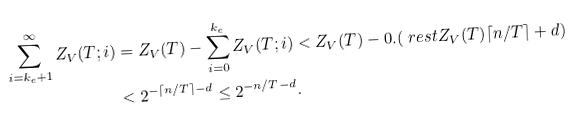<formula> <loc_0><loc_0><loc_500><loc_500>\sum _ { i = k _ { e } + 1 } ^ { \infty } Z _ { V } ( T ; i ) & = Z _ { V } ( T ) - \sum _ { i = 0 } ^ { k _ { e } } Z _ { V } ( T ; i ) < Z _ { V } ( T ) - 0 . ( \ r e s t { Z _ { V } ( T ) } { \lceil n / T \rceil + d } ) \\ & < 2 ^ { - \lceil n / T \rceil - d } \leq 2 ^ { - n / T - d } .</formula> 